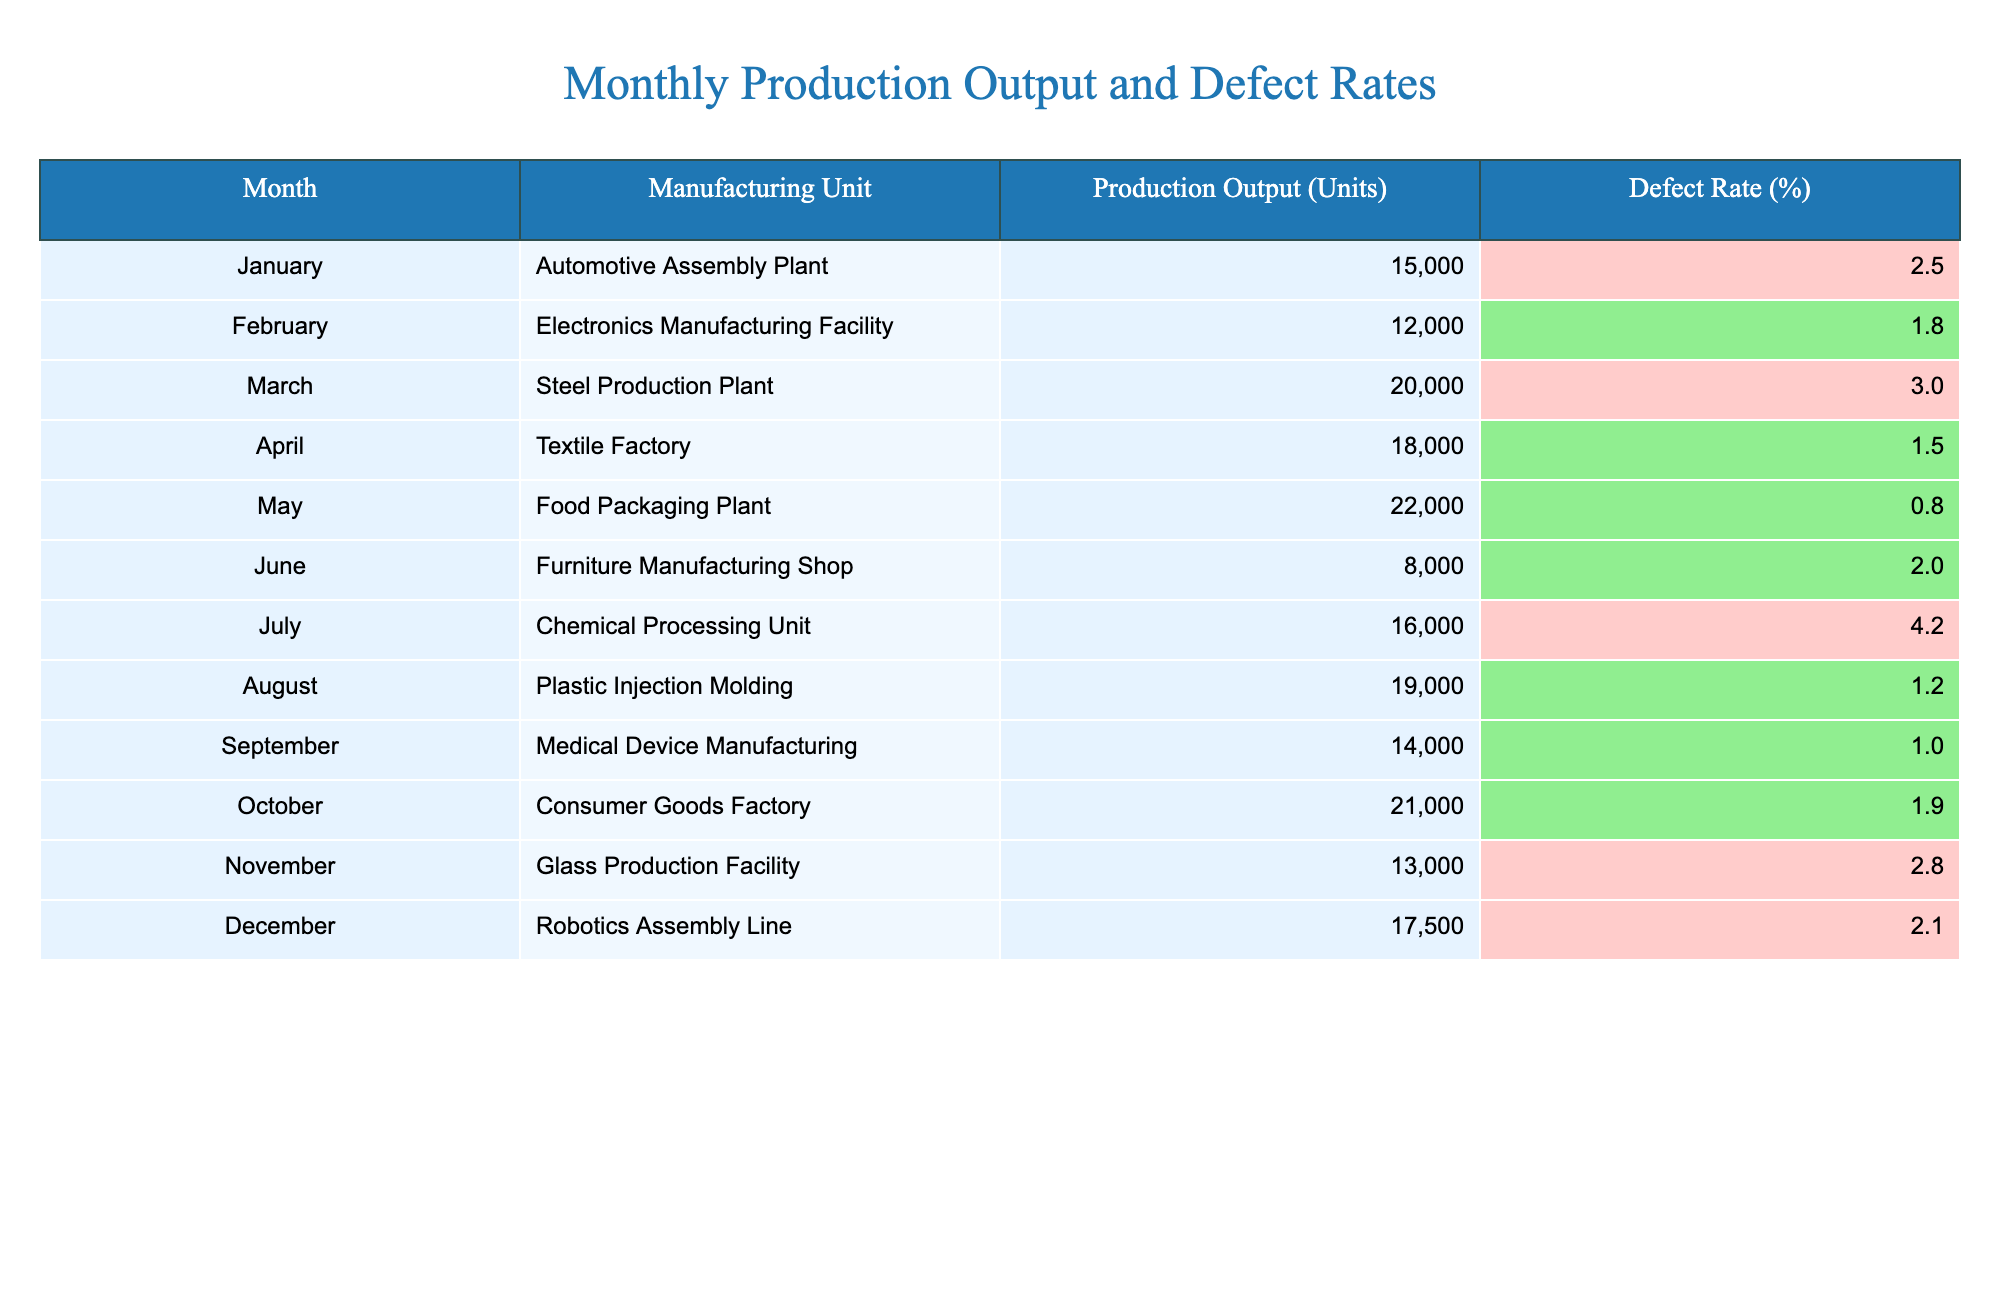What was the production output for the Food Packaging Plant in May? The table shows that the production output for the Food Packaging Plant in May is listed as 22000 units.
Answer: 22000 units Which manufacturing unit had the highest defect rate? By examining the defect rates in the table, the Chemical Processing Unit has the highest defect rate of 4.2%.
Answer: Chemical Processing Unit What is the average production output from January to April? To find the average from January to April, we sum the production outputs for these months: 15000 + 12000 + 20000 + 18000 = 65000 units. There are 4 months, so the average is 65000/4 = 16250 units.
Answer: 16250 units Is the defect rate for the Medical Device Manufacturing unit less than 2%? The table states the defect rate for the Medical Device Manufacturing unit is 1.0%, which is indeed less than 2%.
Answer: Yes Which month has the lowest production output, and what is that output? Looking through the table, June has the lowest production output of 8000 units, as it is smaller than all other monthly outputs listed.
Answer: 8000 units What is the total production output for all units in the last quarter (October to December)? The total production output in the last quarter can be calculated by summing the outputs for October (21000), November (13000), and December (17500): 21000 + 13000 + 17500 = 51500 units.
Answer: 51500 units Did more units produce a defect rate above 2% or below 2%? Counting from the table, there are 4 units (Automotive Assembly Plant, Steel Production Plant, Chemical Processing Unit, Glass Production Facility) with defect rates above 2% and 8 units with defect rates below 2%. Therefore, more units produced below 2%.
Answer: Below 2% What is the difference in production output between the Electronics Manufacturing Facility and the Plastic Injection Molding? The production output for the Electronics Manufacturing Facility is 12000 units and for Plastic Injection Molding is 19000 units. The difference is calculated as 19000 - 12000 = 7000 units.
Answer: 7000 units Which month had a defect rate of 1.5%? Referring to the table, the Textile Factory in April had a defect rate of 1.5%.
Answer: April 